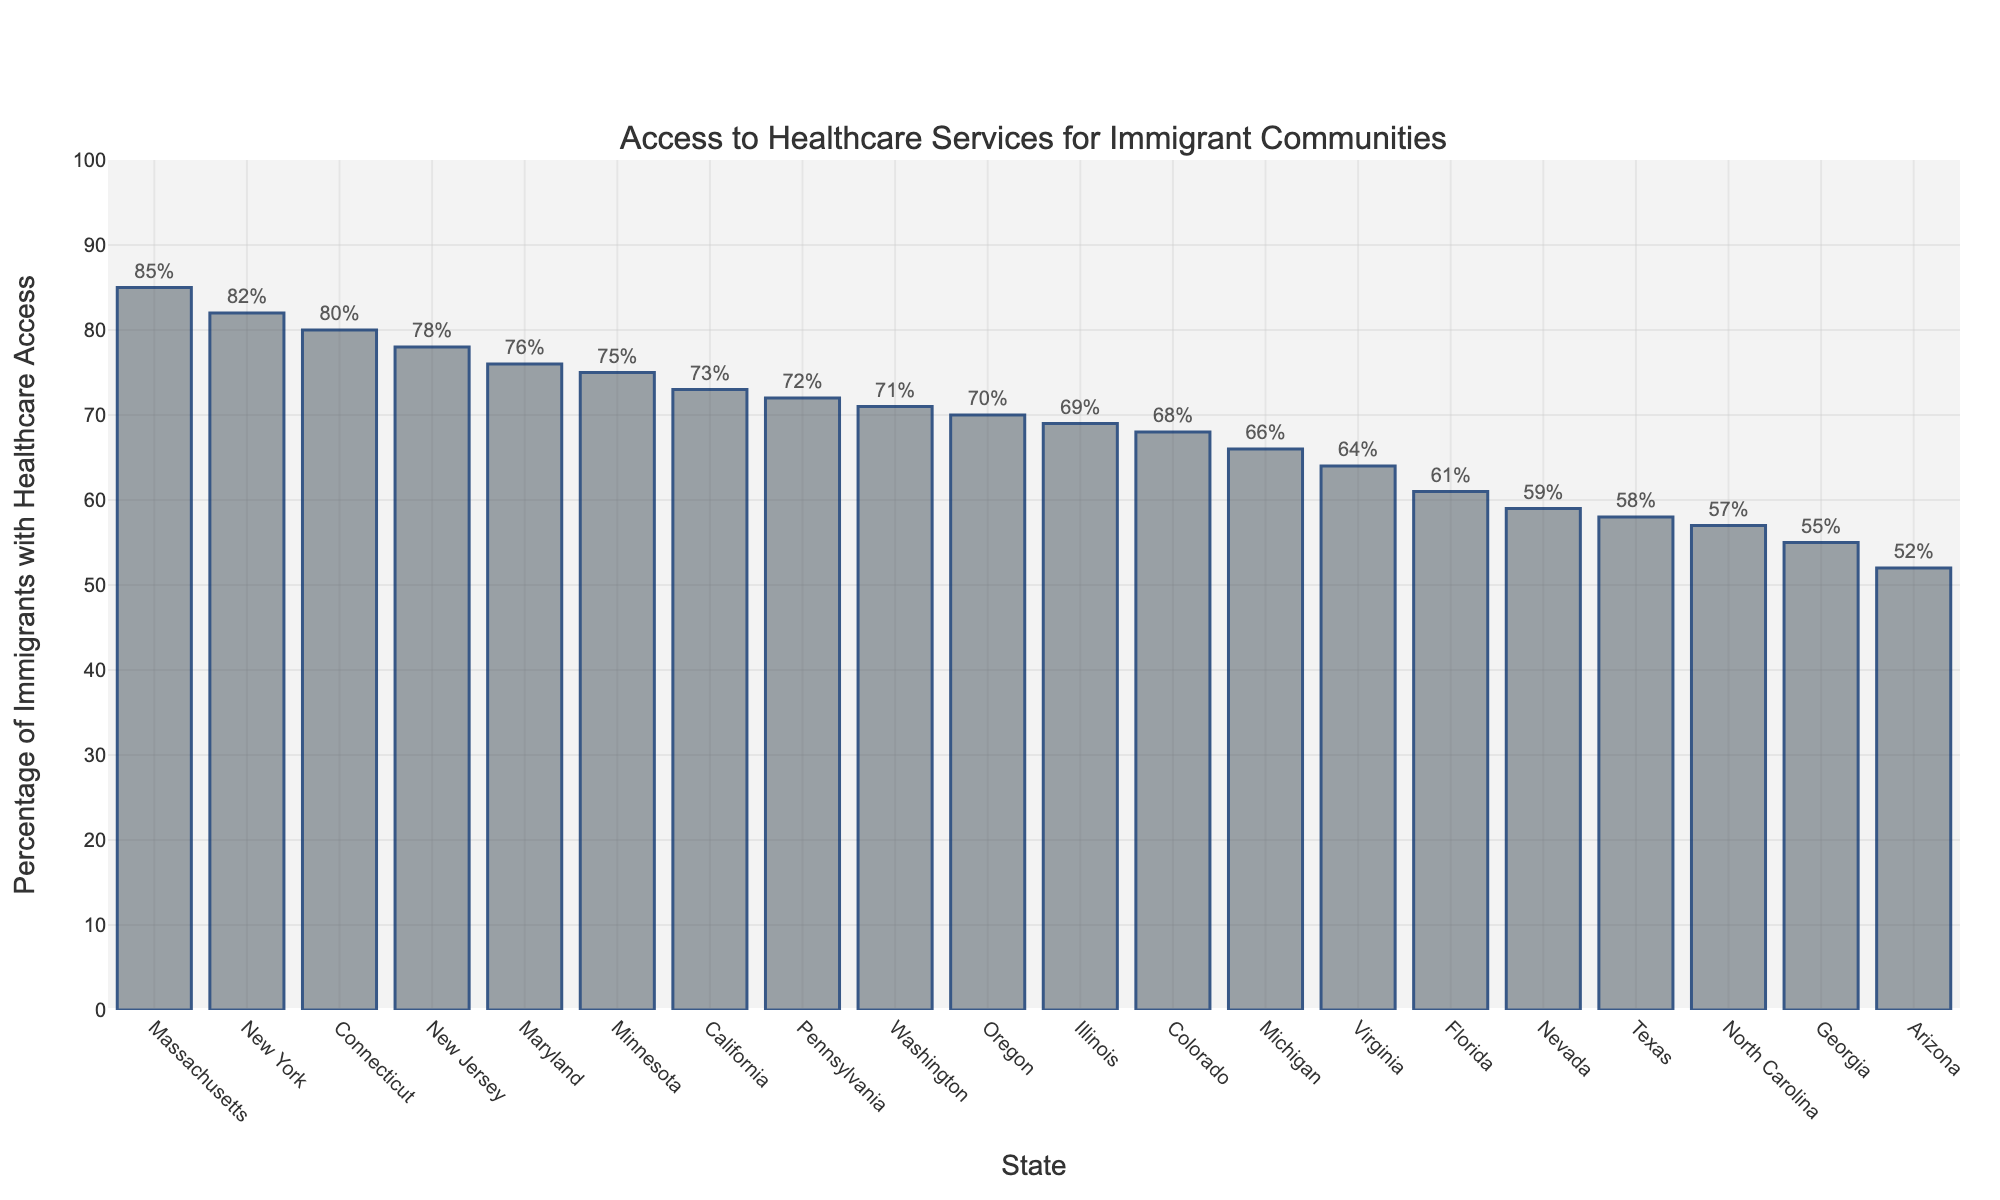what percentage of immigrants in California have access to healthcare services? Refer to the bar labeled "California". The label shows the height representing the percentage value.
Answer: 73% which state has the highest percentage of immigrants with healthcare access? Look for the tallest bar in the chart, which represents the highest percentage.
Answer: Massachusetts which states have less than 60% of immigrants with healthcare access? Identify the bars that do not reach the 60% mark on the y-axis. These states are lower than 60%.
Answer: Arizona, Texas, North Carolina, Georgia how does Virginia compare to Maryland in terms of immigrant healthcare access? Locate the bars for Virginia and Maryland. Compare their heights and the numerical values displayed.
Answer: Maryland has a higher percentage what is the average percentage of immigrant healthcare access in Massachusetts, Connecticut, and New York? Sum the percentages of the three states (85 + 80 + 82) and divide by 3.
Answer: 82.33% how much higher is New York's percentage compared to Texas? Subtract Texas's percentage from New York's percentage (82 - 58).
Answer: 24% is the healthcare access percentage for immigrants in Colorado above the overall average? First, calculate the average percentage of all states, then compare Colorado's percentage to this average.
Answer: Yes which states have healthcare access percentages between 70% and 80%? Identify the bars whose heights represent percentages falling in the 70%-80% range.
Answer: Washington, New Jersey, Maryland, Oregon what portion of the states have healthcare access percentages above 75%? Count the number of states with percentages above 75% and divide by the total number of states, then multiply by 100 for the percentage.
Answer: 20% how does the healthcare access percentage for immigrants in Illinois compare to the overall median? Determine the median by listing all states' percentages in ascending order and find the middle value. Compare this median to Illinois's percentage.
Answer: Below median 